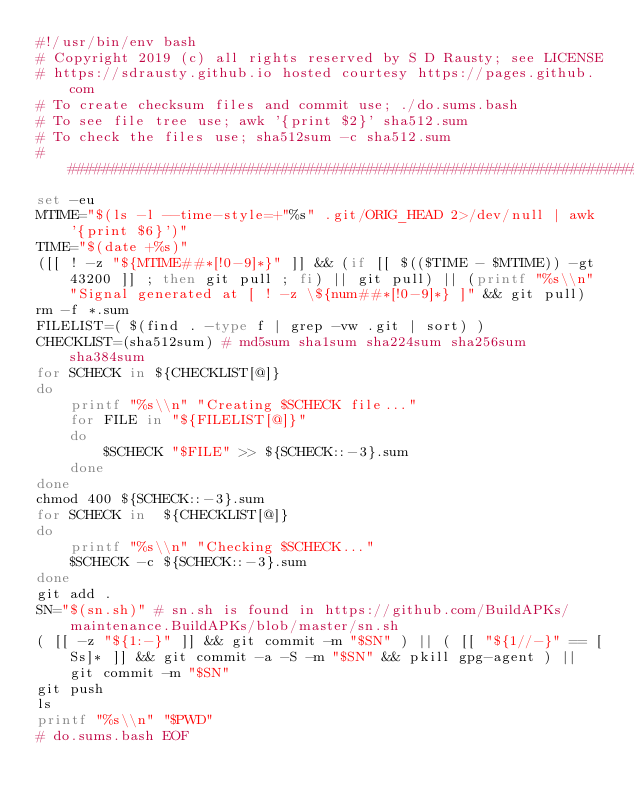<code> <loc_0><loc_0><loc_500><loc_500><_Bash_>#!/usr/bin/env bash
# Copyright 2019 (c) all rights reserved by S D Rausty; see LICENSE  
# https://sdrausty.github.io hosted courtesy https://pages.github.com
# To create checksum files and commit use; ./do.sums.bash
# To see file tree use; awk '{print $2}' sha512.sum
# To check the files use; sha512sum -c sha512.sum
#####################################################################
set -eu
MTIME="$(ls -l --time-style=+"%s" .git/ORIG_HEAD 2>/dev/null | awk '{print $6}')"
TIME="$(date +%s)"
([[ ! -z "${MTIME##*[!0-9]*}" ]] && (if [[ $(($TIME - $MTIME)) -gt 43200 ]] ; then git pull ; fi) || git pull) || (printf "%s\\n" "Signal generated at [ ! -z \${num##*[!0-9]*} ]" && git pull)
rm -f *.sum
FILELIST=( $(find . -type f | grep -vw .git | sort) )
CHECKLIST=(sha512sum) # md5sum sha1sum sha224sum sha256sum sha384sum
for SCHECK in ${CHECKLIST[@]}
do
	printf "%s\\n" "Creating $SCHECK file..."
	for FILE in "${FILELIST[@]}"
	do
		$SCHECK "$FILE" >> ${SCHECK::-3}.sum
	done
done
chmod 400 ${SCHECK::-3}.sum 
for SCHECK in  ${CHECKLIST[@]}
do
	printf "%s\\n" "Checking $SCHECK..."
	$SCHECK -c ${SCHECK::-3}.sum
done
git add .
SN="$(sn.sh)" # sn.sh is found in https://github.com/BuildAPKs/maintenance.BuildAPKs/blob/master/sn.sh
( [[ -z "${1:-}" ]] && git commit -m "$SN" ) || ( [[ "${1//-}" == [Ss]* ]] && git commit -a -S -m "$SN" && pkill gpg-agent ) || git commit -m "$SN"
git push
ls
printf "%s\\n" "$PWD"
# do.sums.bash EOF
</code> 